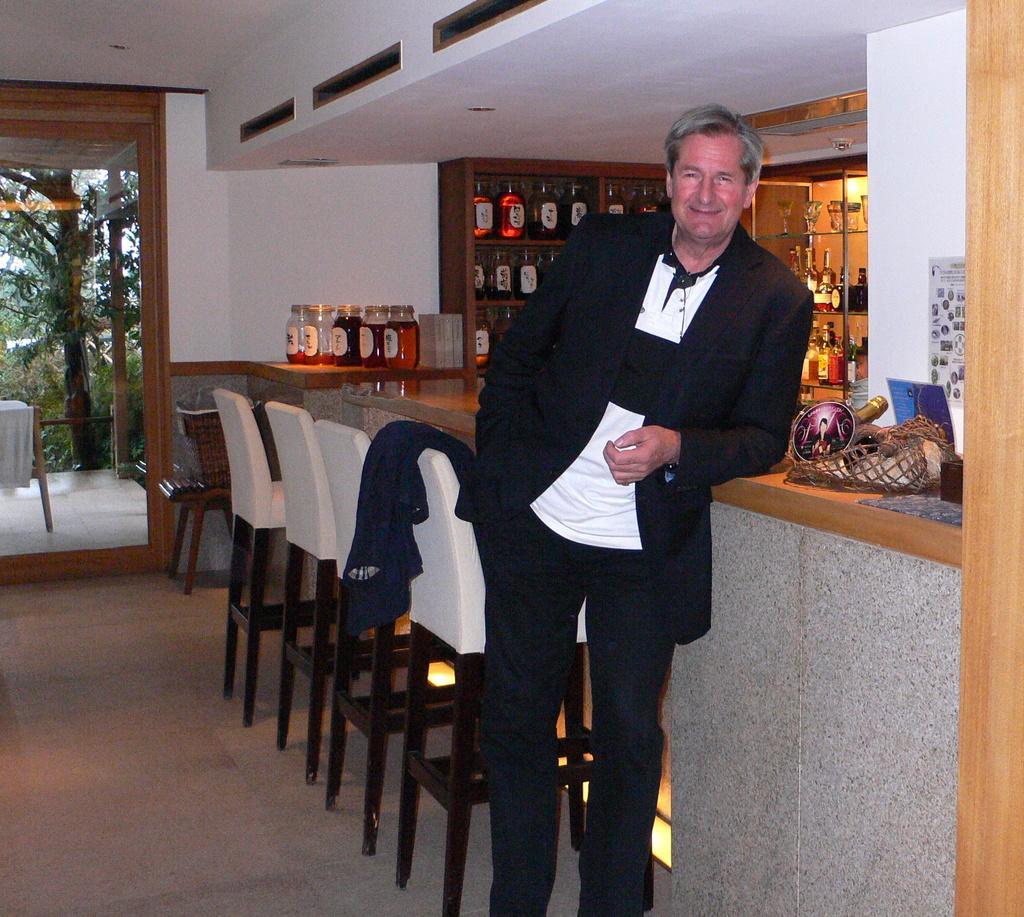Describe this image in one or two sentences. This image is clicked in a room where it has so many chairs, bottles, glasses. There is a tree on the left side. There is a person standing in the middle he is wearing black color dress. There is a paper pasted on the wall on the right side. 